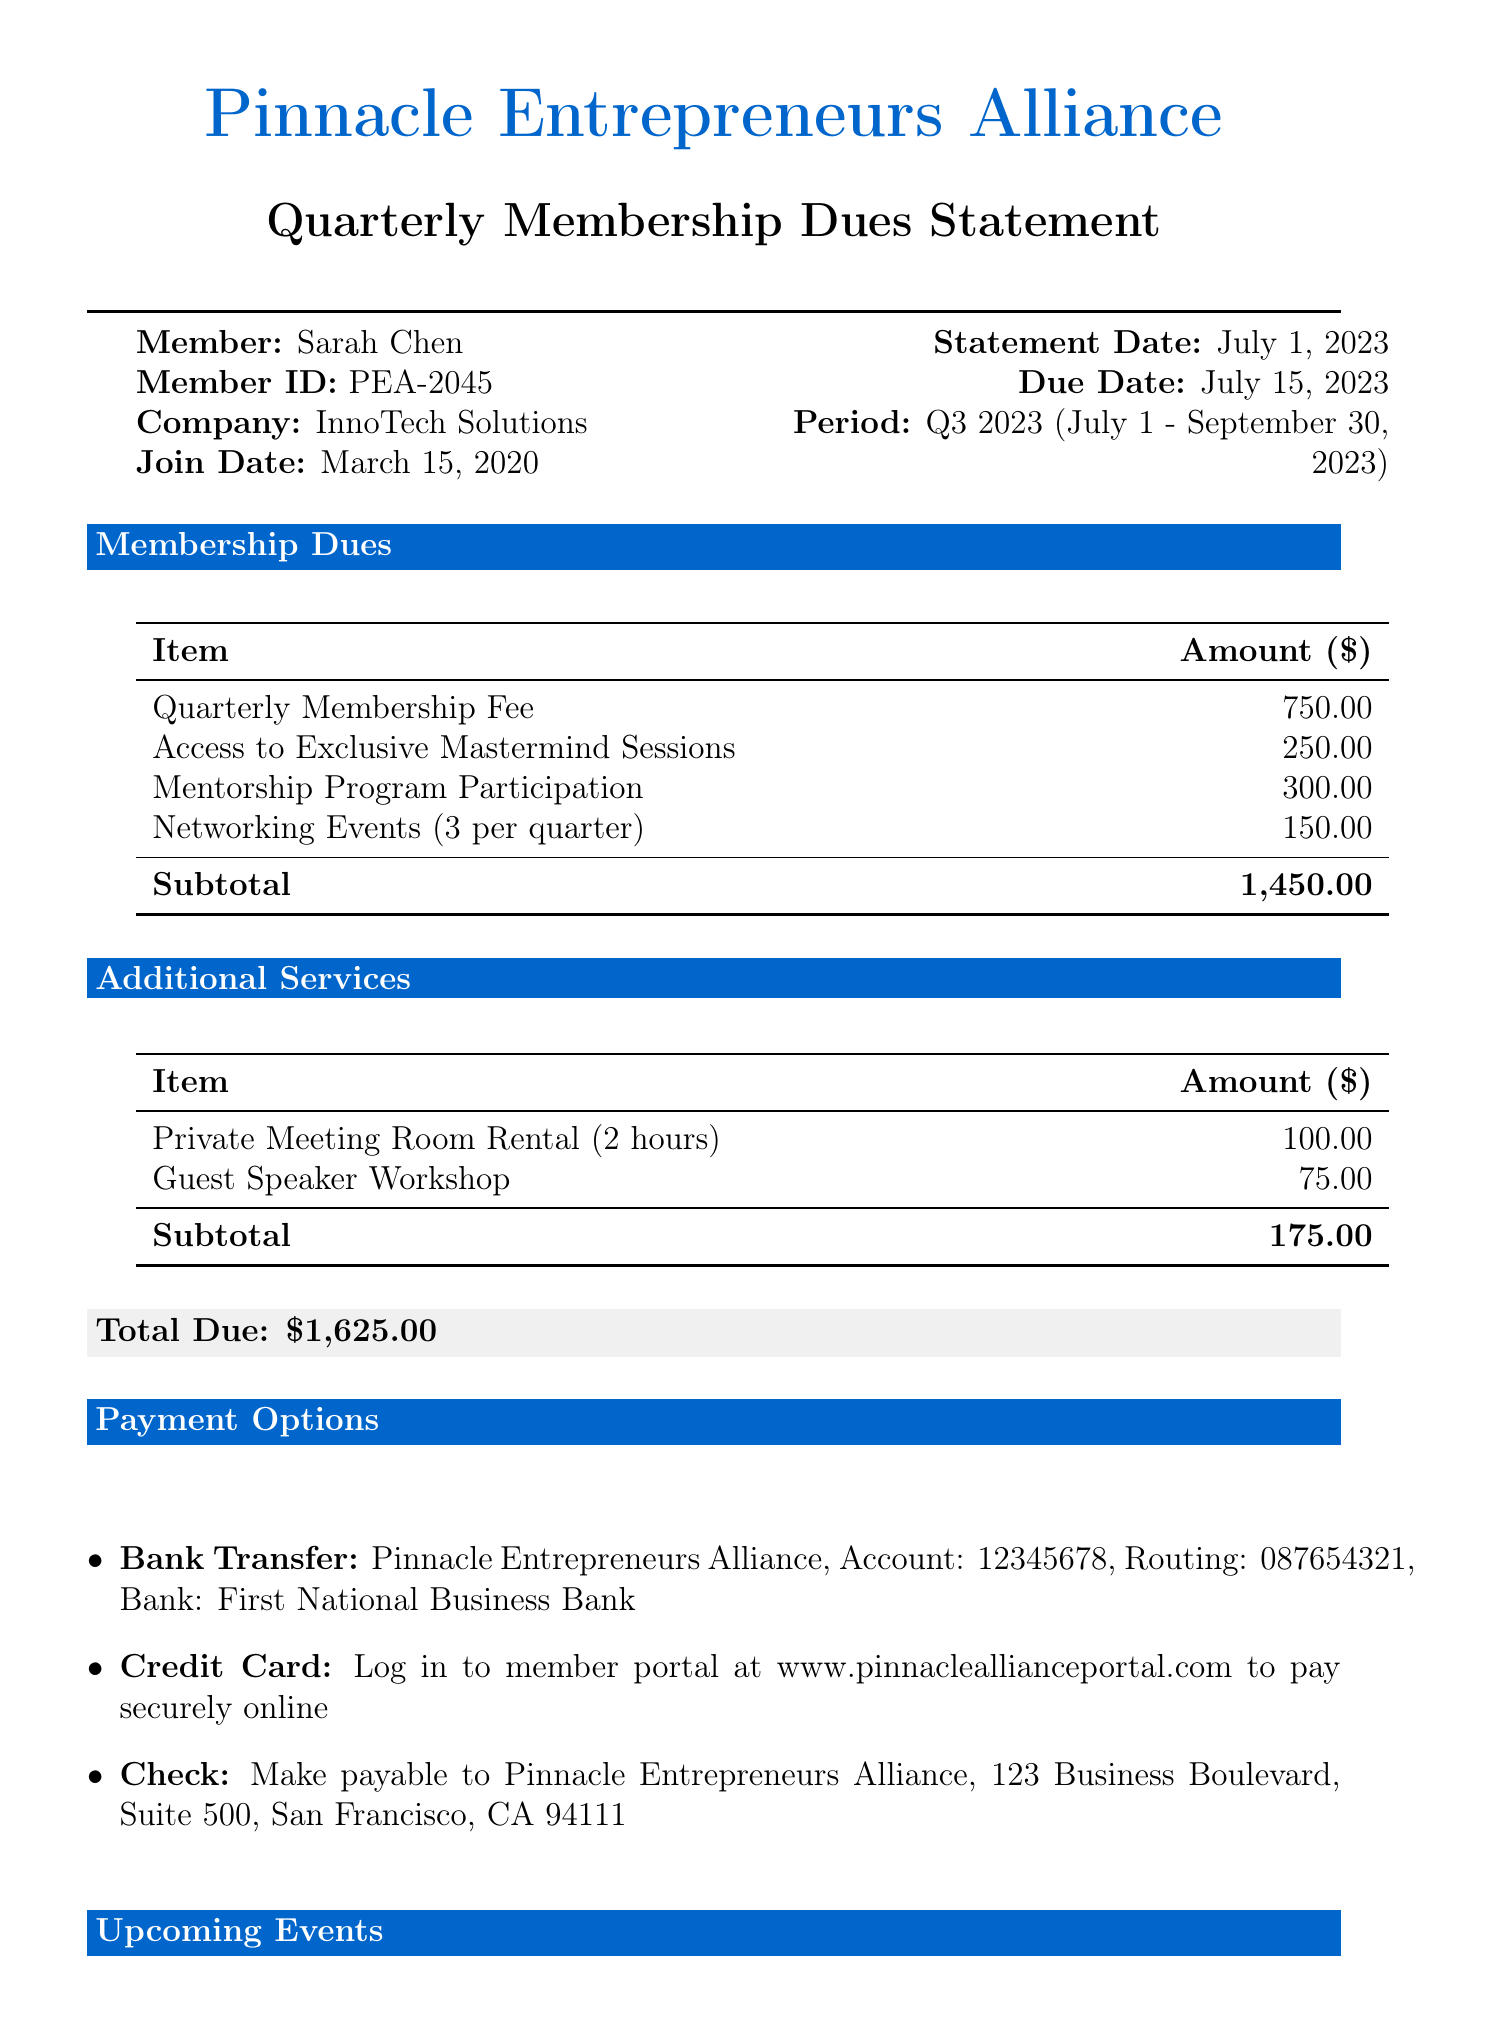What is the statement date? The statement date is explicitly mentioned in the document, which is July 1, 2023.
Answer: July 1, 2023 What is the due date for the membership dues? The due date is specified in the document as July 15, 2023.
Answer: July 15, 2023 What is the total amount due? The total due is the sum of all listed amounts in the statements, explicitly calculated as $1,625.00.
Answer: $1,625.00 Who is the membership director? The document contains contact information stating that Jessica Thompson is the membership director.
Answer: Jessica Thompson How many networking events are included per quarter? The document specifically states that there are 3 networking events per quarter.
Answer: 3 What is the late charge fee percentage? The late payment policy in the document indicates that the late charge fee is 5% of the outstanding balance.
Answer: 5% What is the membership period mentioned in the document? The membership period is detailed in the document as Q3 2023 (July 1 - September 30, 2023).
Answer: Q3 2023 (July 1 - September 30, 2023) Which event is scheduled for August 15, 2023? The document lists an upcoming event, Scaling Your Startup: Lessons from Unicorn Founders, scheduled for this date.
Answer: Scaling Your Startup: Lessons from Unicorn Founders What is required to pay by credit card? The payment options state that members need to log in to the member portal at a specific website to pay securely online.
Answer: Log in to member portal at www.pinnacleallianceportal.com 